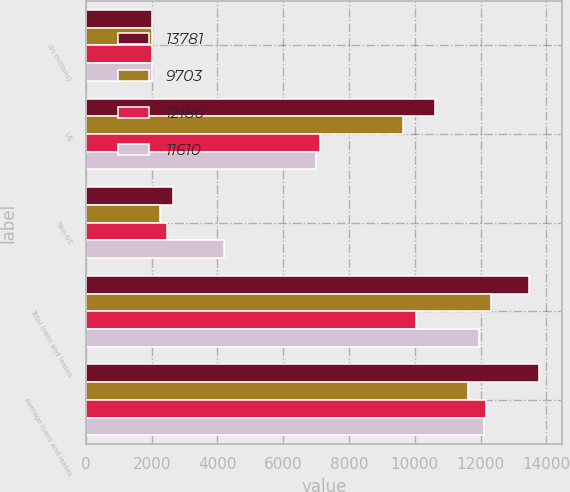Convert chart to OTSL. <chart><loc_0><loc_0><loc_500><loc_500><stacked_bar_chart><ecel><fcel>(In millions)<fcel>US<fcel>Non-US<fcel>Total loans and leases<fcel>Average loans and leases<nl><fcel>13781<fcel>2013<fcel>10623<fcel>2654<fcel>13486<fcel>13781<nl><fcel>9703<fcel>2012<fcel>9645<fcel>2251<fcel>12307<fcel>11610<nl><fcel>12180<fcel>2011<fcel>7115<fcel>2478<fcel>10053<fcel>12180<nl><fcel>11610<fcel>2010<fcel>7001<fcel>4192<fcel>11957<fcel>12094<nl></chart> 